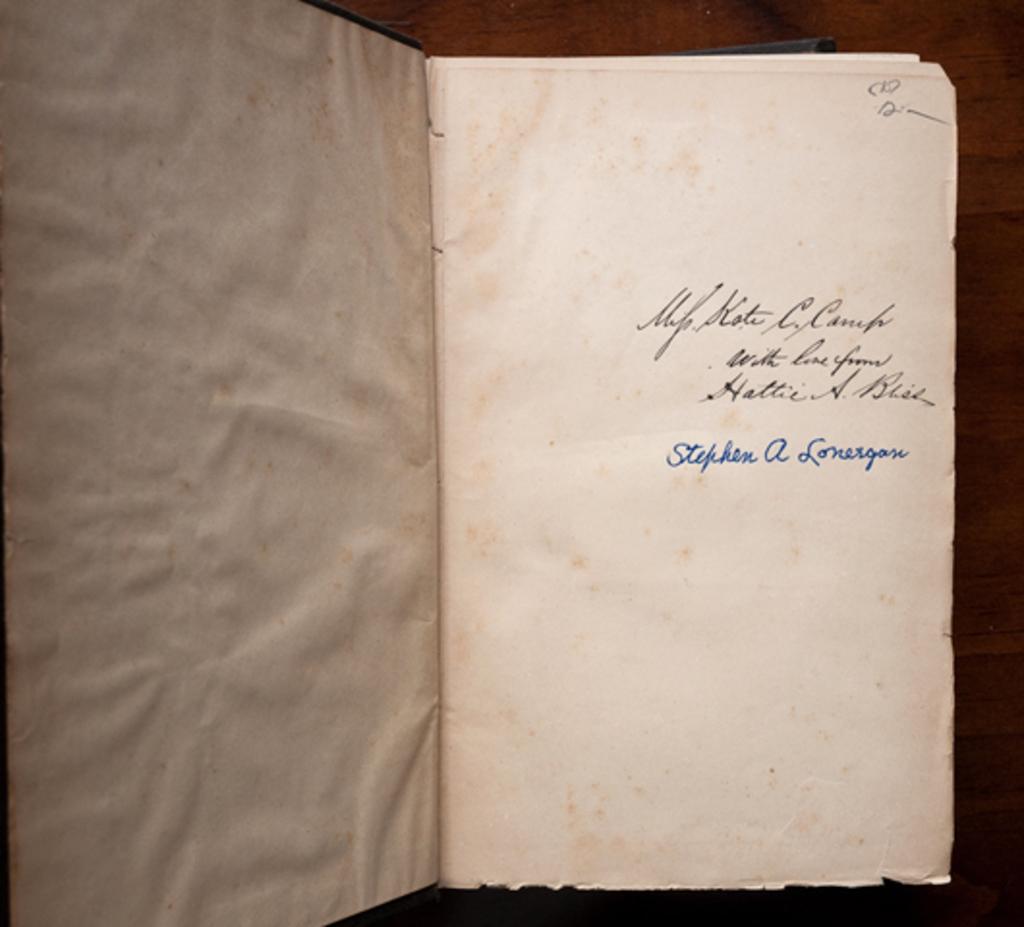Who signed in blue ink?
Make the answer very short. Stephen a lonesgan. 